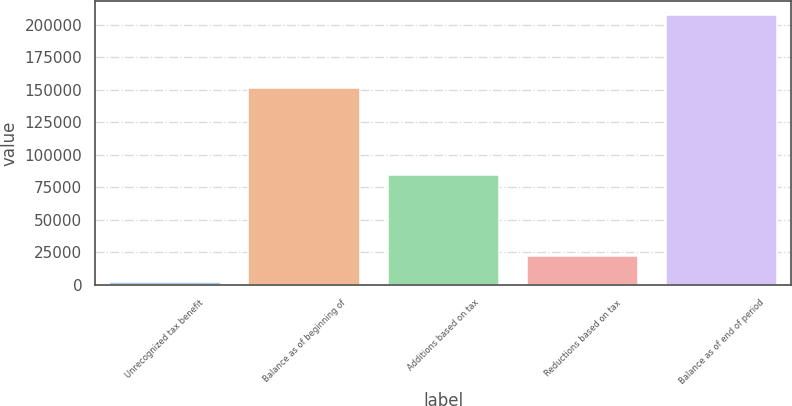Convert chart. <chart><loc_0><loc_0><loc_500><loc_500><bar_chart><fcel>Unrecognized tax benefit<fcel>Balance as of beginning of<fcel>Additions based on tax<fcel>Reductions based on tax<fcel>Balance as of end of period<nl><fcel>2014<fcel>151353<fcel>84278.4<fcel>22580.1<fcel>207675<nl></chart> 